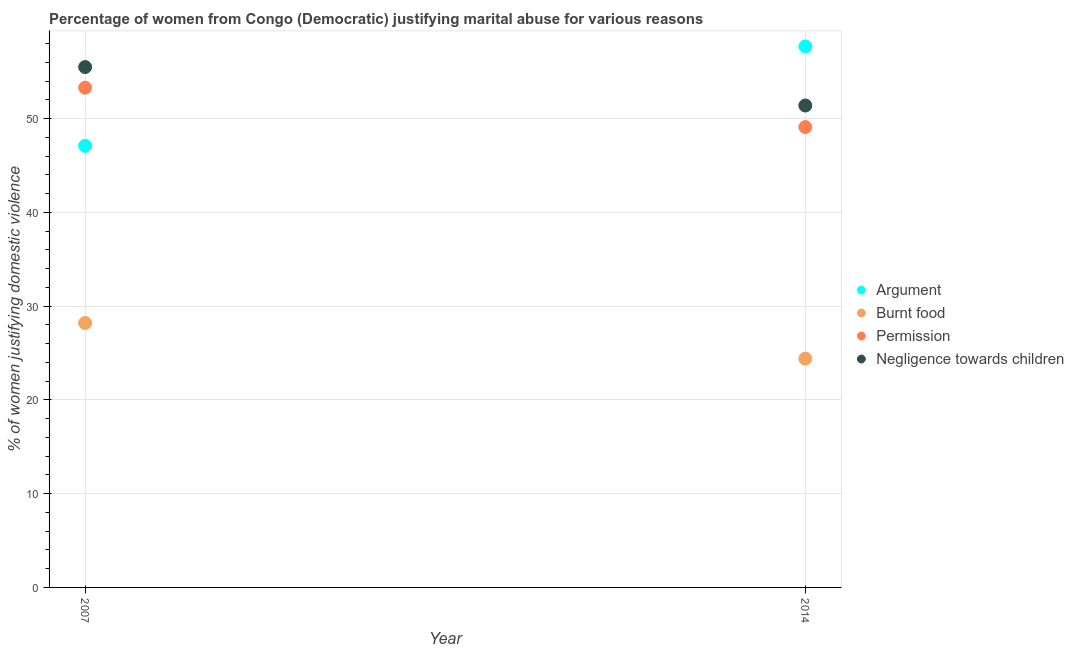How many different coloured dotlines are there?
Your response must be concise. 4. Is the number of dotlines equal to the number of legend labels?
Give a very brief answer. Yes. What is the percentage of women justifying abuse in the case of an argument in 2014?
Make the answer very short. 57.7. Across all years, what is the maximum percentage of women justifying abuse for showing negligence towards children?
Offer a very short reply. 55.5. Across all years, what is the minimum percentage of women justifying abuse for going without permission?
Offer a terse response. 49.1. What is the total percentage of women justifying abuse for going without permission in the graph?
Your answer should be very brief. 102.4. What is the difference between the percentage of women justifying abuse for showing negligence towards children in 2007 and that in 2014?
Your answer should be compact. 4.1. What is the difference between the percentage of women justifying abuse in the case of an argument in 2007 and the percentage of women justifying abuse for going without permission in 2014?
Offer a terse response. -2. What is the average percentage of women justifying abuse for going without permission per year?
Offer a terse response. 51.2. In the year 2014, what is the difference between the percentage of women justifying abuse for going without permission and percentage of women justifying abuse for showing negligence towards children?
Offer a very short reply. -2.3. In how many years, is the percentage of women justifying abuse for burning food greater than 4 %?
Ensure brevity in your answer.  2. What is the ratio of the percentage of women justifying abuse for showing negligence towards children in 2007 to that in 2014?
Make the answer very short. 1.08. Is it the case that in every year, the sum of the percentage of women justifying abuse in the case of an argument and percentage of women justifying abuse for going without permission is greater than the sum of percentage of women justifying abuse for showing negligence towards children and percentage of women justifying abuse for burning food?
Offer a very short reply. Yes. Is the percentage of women justifying abuse for going without permission strictly less than the percentage of women justifying abuse for burning food over the years?
Offer a very short reply. No. What is the difference between two consecutive major ticks on the Y-axis?
Offer a very short reply. 10. Are the values on the major ticks of Y-axis written in scientific E-notation?
Your answer should be compact. No. Does the graph contain any zero values?
Keep it short and to the point. No. Does the graph contain grids?
Keep it short and to the point. Yes. How many legend labels are there?
Your answer should be very brief. 4. What is the title of the graph?
Your response must be concise. Percentage of women from Congo (Democratic) justifying marital abuse for various reasons. Does "SF6 gas" appear as one of the legend labels in the graph?
Offer a terse response. No. What is the label or title of the X-axis?
Offer a terse response. Year. What is the label or title of the Y-axis?
Give a very brief answer. % of women justifying domestic violence. What is the % of women justifying domestic violence in Argument in 2007?
Keep it short and to the point. 47.1. What is the % of women justifying domestic violence of Burnt food in 2007?
Provide a short and direct response. 28.2. What is the % of women justifying domestic violence in Permission in 2007?
Offer a terse response. 53.3. What is the % of women justifying domestic violence in Negligence towards children in 2007?
Your response must be concise. 55.5. What is the % of women justifying domestic violence in Argument in 2014?
Provide a short and direct response. 57.7. What is the % of women justifying domestic violence in Burnt food in 2014?
Your answer should be compact. 24.4. What is the % of women justifying domestic violence in Permission in 2014?
Your answer should be compact. 49.1. What is the % of women justifying domestic violence in Negligence towards children in 2014?
Offer a terse response. 51.4. Across all years, what is the maximum % of women justifying domestic violence of Argument?
Your answer should be very brief. 57.7. Across all years, what is the maximum % of women justifying domestic violence of Burnt food?
Make the answer very short. 28.2. Across all years, what is the maximum % of women justifying domestic violence of Permission?
Make the answer very short. 53.3. Across all years, what is the maximum % of women justifying domestic violence in Negligence towards children?
Provide a succinct answer. 55.5. Across all years, what is the minimum % of women justifying domestic violence of Argument?
Offer a terse response. 47.1. Across all years, what is the minimum % of women justifying domestic violence of Burnt food?
Offer a terse response. 24.4. Across all years, what is the minimum % of women justifying domestic violence of Permission?
Make the answer very short. 49.1. Across all years, what is the minimum % of women justifying domestic violence of Negligence towards children?
Provide a succinct answer. 51.4. What is the total % of women justifying domestic violence in Argument in the graph?
Offer a terse response. 104.8. What is the total % of women justifying domestic violence in Burnt food in the graph?
Your response must be concise. 52.6. What is the total % of women justifying domestic violence in Permission in the graph?
Your answer should be compact. 102.4. What is the total % of women justifying domestic violence of Negligence towards children in the graph?
Provide a succinct answer. 106.9. What is the difference between the % of women justifying domestic violence of Burnt food in 2007 and that in 2014?
Offer a terse response. 3.8. What is the difference between the % of women justifying domestic violence in Permission in 2007 and that in 2014?
Provide a succinct answer. 4.2. What is the difference between the % of women justifying domestic violence in Negligence towards children in 2007 and that in 2014?
Provide a short and direct response. 4.1. What is the difference between the % of women justifying domestic violence of Argument in 2007 and the % of women justifying domestic violence of Burnt food in 2014?
Make the answer very short. 22.7. What is the difference between the % of women justifying domestic violence in Argument in 2007 and the % of women justifying domestic violence in Permission in 2014?
Provide a short and direct response. -2. What is the difference between the % of women justifying domestic violence of Burnt food in 2007 and the % of women justifying domestic violence of Permission in 2014?
Give a very brief answer. -20.9. What is the difference between the % of women justifying domestic violence of Burnt food in 2007 and the % of women justifying domestic violence of Negligence towards children in 2014?
Make the answer very short. -23.2. What is the difference between the % of women justifying domestic violence in Permission in 2007 and the % of women justifying domestic violence in Negligence towards children in 2014?
Offer a terse response. 1.9. What is the average % of women justifying domestic violence of Argument per year?
Your response must be concise. 52.4. What is the average % of women justifying domestic violence of Burnt food per year?
Your response must be concise. 26.3. What is the average % of women justifying domestic violence in Permission per year?
Keep it short and to the point. 51.2. What is the average % of women justifying domestic violence in Negligence towards children per year?
Your answer should be compact. 53.45. In the year 2007, what is the difference between the % of women justifying domestic violence of Argument and % of women justifying domestic violence of Burnt food?
Your answer should be very brief. 18.9. In the year 2007, what is the difference between the % of women justifying domestic violence of Argument and % of women justifying domestic violence of Negligence towards children?
Offer a very short reply. -8.4. In the year 2007, what is the difference between the % of women justifying domestic violence in Burnt food and % of women justifying domestic violence in Permission?
Offer a terse response. -25.1. In the year 2007, what is the difference between the % of women justifying domestic violence of Burnt food and % of women justifying domestic violence of Negligence towards children?
Keep it short and to the point. -27.3. In the year 2007, what is the difference between the % of women justifying domestic violence of Permission and % of women justifying domestic violence of Negligence towards children?
Keep it short and to the point. -2.2. In the year 2014, what is the difference between the % of women justifying domestic violence in Argument and % of women justifying domestic violence in Burnt food?
Offer a terse response. 33.3. In the year 2014, what is the difference between the % of women justifying domestic violence in Burnt food and % of women justifying domestic violence in Permission?
Your response must be concise. -24.7. In the year 2014, what is the difference between the % of women justifying domestic violence of Burnt food and % of women justifying domestic violence of Negligence towards children?
Your answer should be compact. -27. In the year 2014, what is the difference between the % of women justifying domestic violence of Permission and % of women justifying domestic violence of Negligence towards children?
Ensure brevity in your answer.  -2.3. What is the ratio of the % of women justifying domestic violence of Argument in 2007 to that in 2014?
Offer a terse response. 0.82. What is the ratio of the % of women justifying domestic violence of Burnt food in 2007 to that in 2014?
Provide a short and direct response. 1.16. What is the ratio of the % of women justifying domestic violence of Permission in 2007 to that in 2014?
Your response must be concise. 1.09. What is the ratio of the % of women justifying domestic violence in Negligence towards children in 2007 to that in 2014?
Provide a succinct answer. 1.08. What is the difference between the highest and the second highest % of women justifying domestic violence of Argument?
Offer a terse response. 10.6. What is the difference between the highest and the second highest % of women justifying domestic violence of Negligence towards children?
Offer a terse response. 4.1. What is the difference between the highest and the lowest % of women justifying domestic violence in Argument?
Keep it short and to the point. 10.6. What is the difference between the highest and the lowest % of women justifying domestic violence of Burnt food?
Give a very brief answer. 3.8. What is the difference between the highest and the lowest % of women justifying domestic violence in Permission?
Your answer should be very brief. 4.2. 